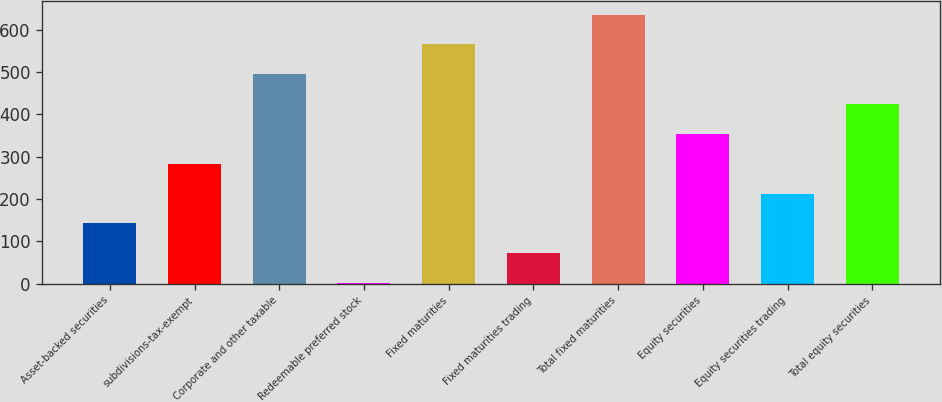Convert chart. <chart><loc_0><loc_0><loc_500><loc_500><bar_chart><fcel>Asset-backed securities<fcel>subdivisions-tax-exempt<fcel>Corporate and other taxable<fcel>Redeemable preferred stock<fcel>Fixed maturities<fcel>Fixed maturities trading<fcel>Total fixed maturities<fcel>Equity securities<fcel>Equity securities trading<fcel>Total equity securities<nl><fcel>142.2<fcel>283.4<fcel>495.2<fcel>1<fcel>565.8<fcel>71.6<fcel>636.4<fcel>354<fcel>212.8<fcel>424.6<nl></chart> 